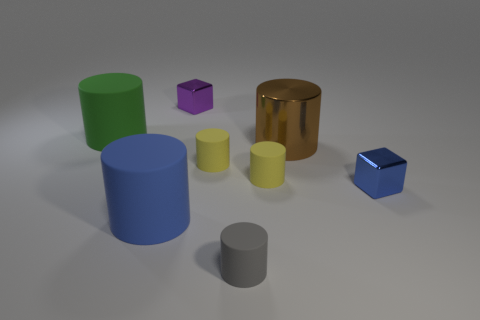Subtract all large brown metal cylinders. How many cylinders are left? 5 Subtract all purple spheres. How many yellow cylinders are left? 2 Subtract 4 cylinders. How many cylinders are left? 2 Add 1 brown rubber spheres. How many objects exist? 9 Subtract all green cylinders. How many cylinders are left? 5 Subtract all cylinders. How many objects are left? 2 Subtract all red cylinders. Subtract all green cubes. How many cylinders are left? 6 Add 6 blue rubber cylinders. How many blue rubber cylinders are left? 7 Add 8 brown shiny objects. How many brown shiny objects exist? 9 Subtract 0 red spheres. How many objects are left? 8 